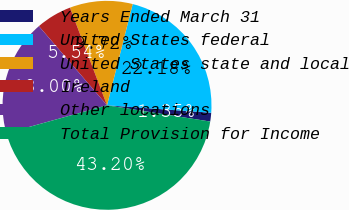Convert chart. <chart><loc_0><loc_0><loc_500><loc_500><pie_chart><fcel>Years Ended March 31<fcel>United States federal<fcel>United States state and local<fcel>Ireland<fcel>Other locations<fcel>Total Provision for Income<nl><fcel>1.35%<fcel>22.18%<fcel>9.72%<fcel>5.54%<fcel>18.0%<fcel>43.2%<nl></chart> 